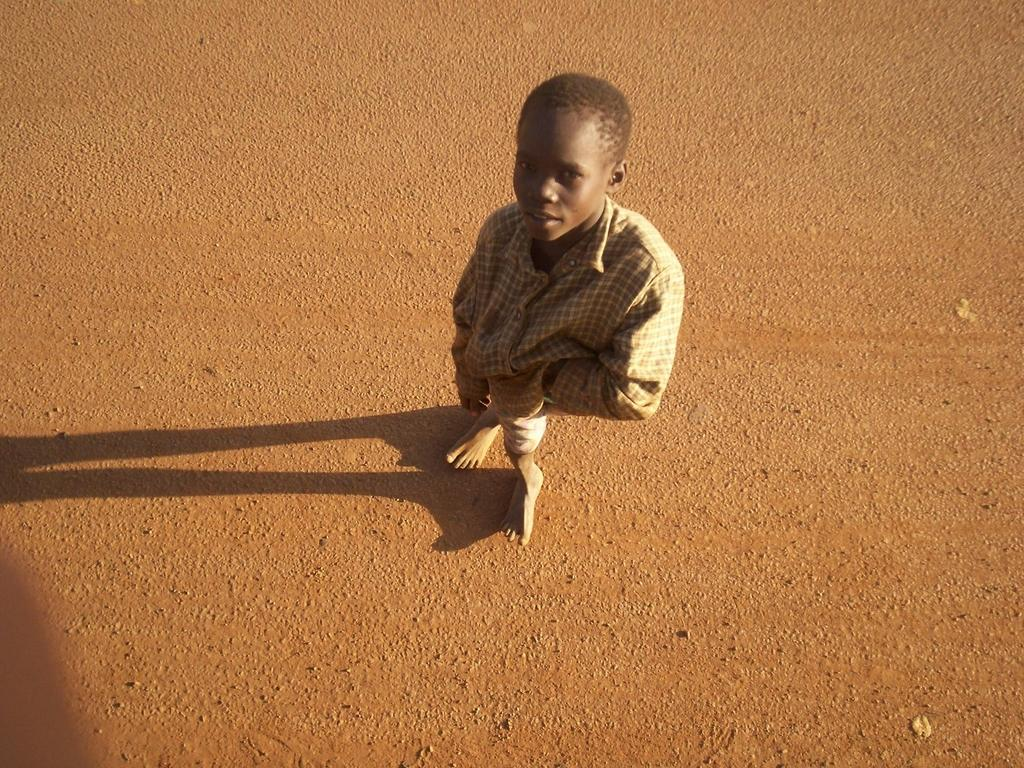Who is present in the image? There is a person in the image. Where is the person located? The person is standing on the road. What is the relationship between the mother and son in the image? There is no mention of a mother or son in the image, as the facts only state that there is a person standing on the road. 